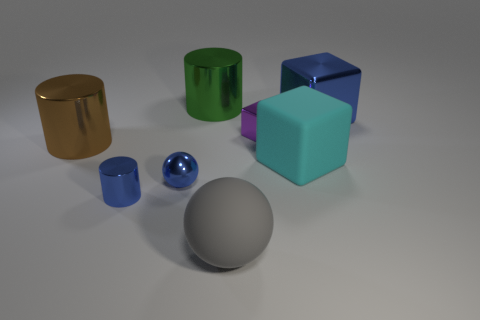Subtract 0 red blocks. How many objects are left? 8 Subtract all spheres. How many objects are left? 6 Subtract 1 spheres. How many spheres are left? 1 Subtract all green cylinders. Subtract all yellow spheres. How many cylinders are left? 2 Subtract all purple cylinders. How many yellow balls are left? 0 Subtract all large gray matte spheres. Subtract all large gray objects. How many objects are left? 6 Add 4 large brown metal objects. How many large brown metal objects are left? 5 Add 5 small things. How many small things exist? 8 Add 2 big blue metallic things. How many objects exist? 10 Subtract all blue cylinders. How many cylinders are left? 2 